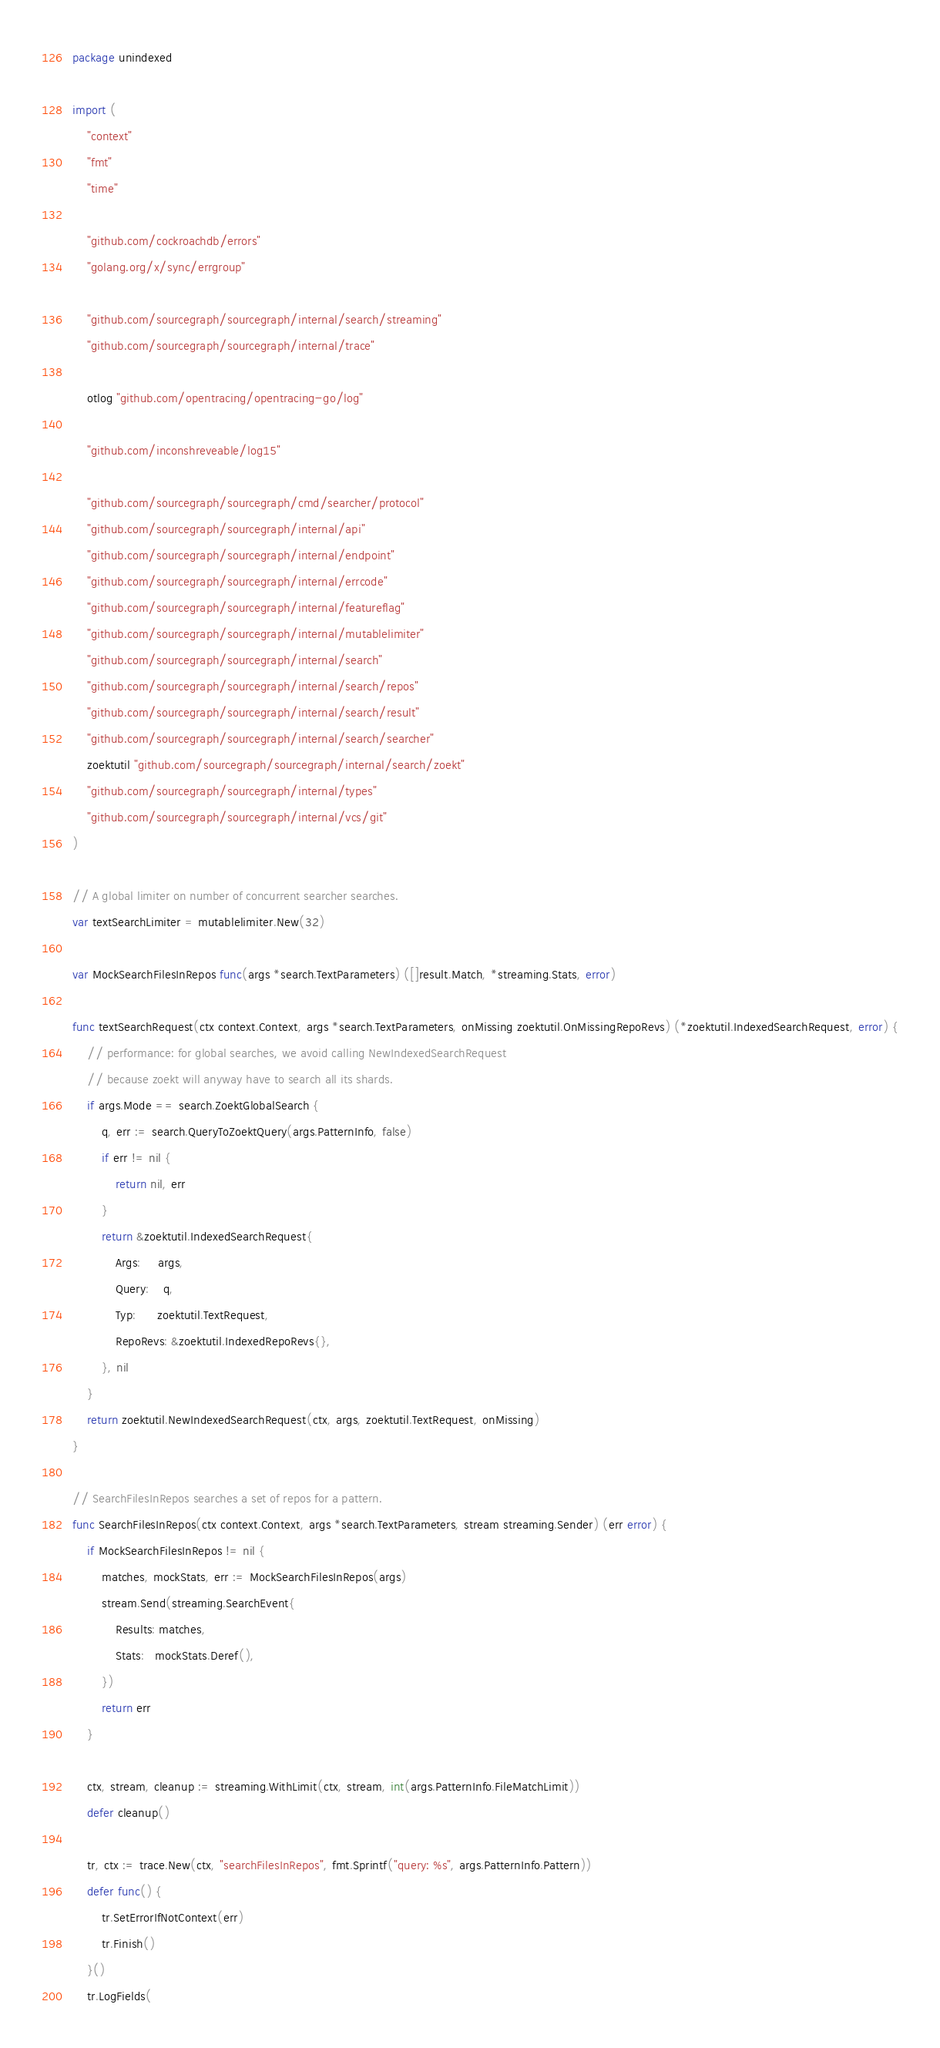<code> <loc_0><loc_0><loc_500><loc_500><_Go_>package unindexed

import (
	"context"
	"fmt"
	"time"

	"github.com/cockroachdb/errors"
	"golang.org/x/sync/errgroup"

	"github.com/sourcegraph/sourcegraph/internal/search/streaming"
	"github.com/sourcegraph/sourcegraph/internal/trace"

	otlog "github.com/opentracing/opentracing-go/log"

	"github.com/inconshreveable/log15"

	"github.com/sourcegraph/sourcegraph/cmd/searcher/protocol"
	"github.com/sourcegraph/sourcegraph/internal/api"
	"github.com/sourcegraph/sourcegraph/internal/endpoint"
	"github.com/sourcegraph/sourcegraph/internal/errcode"
	"github.com/sourcegraph/sourcegraph/internal/featureflag"
	"github.com/sourcegraph/sourcegraph/internal/mutablelimiter"
	"github.com/sourcegraph/sourcegraph/internal/search"
	"github.com/sourcegraph/sourcegraph/internal/search/repos"
	"github.com/sourcegraph/sourcegraph/internal/search/result"
	"github.com/sourcegraph/sourcegraph/internal/search/searcher"
	zoektutil "github.com/sourcegraph/sourcegraph/internal/search/zoekt"
	"github.com/sourcegraph/sourcegraph/internal/types"
	"github.com/sourcegraph/sourcegraph/internal/vcs/git"
)

// A global limiter on number of concurrent searcher searches.
var textSearchLimiter = mutablelimiter.New(32)

var MockSearchFilesInRepos func(args *search.TextParameters) ([]result.Match, *streaming.Stats, error)

func textSearchRequest(ctx context.Context, args *search.TextParameters, onMissing zoektutil.OnMissingRepoRevs) (*zoektutil.IndexedSearchRequest, error) {
	// performance: for global searches, we avoid calling NewIndexedSearchRequest
	// because zoekt will anyway have to search all its shards.
	if args.Mode == search.ZoektGlobalSearch {
		q, err := search.QueryToZoektQuery(args.PatternInfo, false)
		if err != nil {
			return nil, err
		}
		return &zoektutil.IndexedSearchRequest{
			Args:     args,
			Query:    q,
			Typ:      zoektutil.TextRequest,
			RepoRevs: &zoektutil.IndexedRepoRevs{},
		}, nil
	}
	return zoektutil.NewIndexedSearchRequest(ctx, args, zoektutil.TextRequest, onMissing)
}

// SearchFilesInRepos searches a set of repos for a pattern.
func SearchFilesInRepos(ctx context.Context, args *search.TextParameters, stream streaming.Sender) (err error) {
	if MockSearchFilesInRepos != nil {
		matches, mockStats, err := MockSearchFilesInRepos(args)
		stream.Send(streaming.SearchEvent{
			Results: matches,
			Stats:   mockStats.Deref(),
		})
		return err
	}

	ctx, stream, cleanup := streaming.WithLimit(ctx, stream, int(args.PatternInfo.FileMatchLimit))
	defer cleanup()

	tr, ctx := trace.New(ctx, "searchFilesInRepos", fmt.Sprintf("query: %s", args.PatternInfo.Pattern))
	defer func() {
		tr.SetErrorIfNotContext(err)
		tr.Finish()
	}()
	tr.LogFields(</code> 